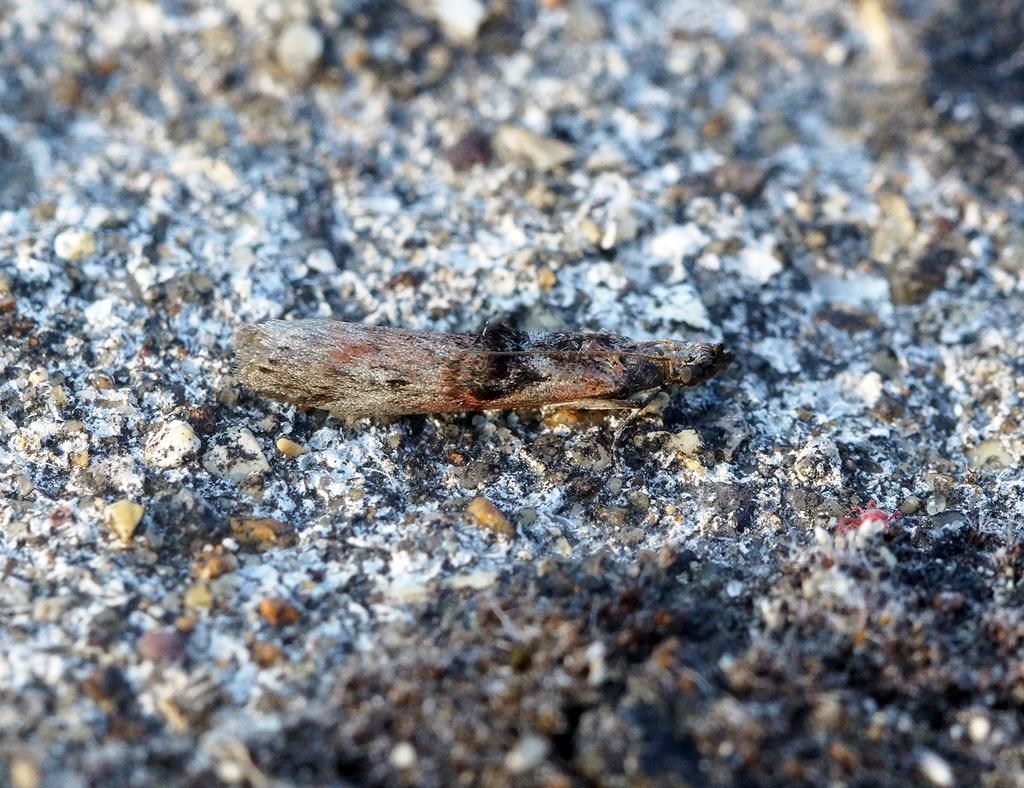What type of material is present in the image? There is a piece of wood in the image. What other natural materials can be seen in the image? There are stones in the image. What might be the result of a fire in the image? There is ash visible in the image, which suggests a fire has occurred. What angle is the doctor leaning at in the image? There is no doctor present in the image. What discovery was made by the angle in the image? There is no angle or discovery mentioned in the image. 